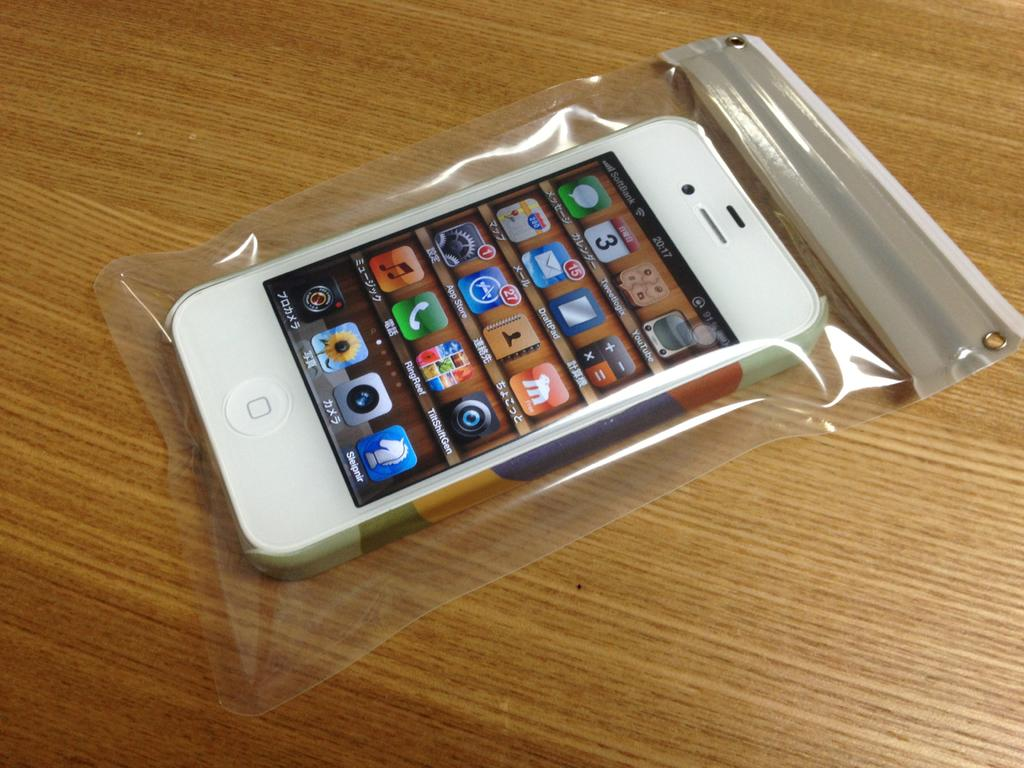<image>
Share a concise interpretation of the image provided. Old iPhone 4 inside of a Ziploc bag showing the time to be 20:17. 